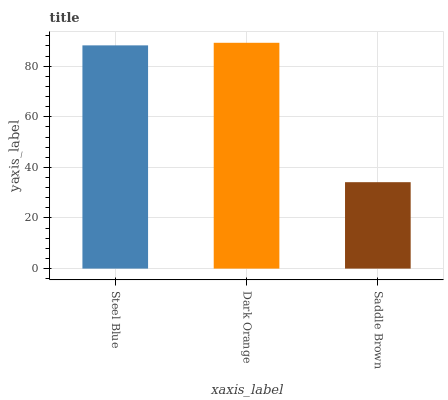Is Dark Orange the minimum?
Answer yes or no. No. Is Saddle Brown the maximum?
Answer yes or no. No. Is Dark Orange greater than Saddle Brown?
Answer yes or no. Yes. Is Saddle Brown less than Dark Orange?
Answer yes or no. Yes. Is Saddle Brown greater than Dark Orange?
Answer yes or no. No. Is Dark Orange less than Saddle Brown?
Answer yes or no. No. Is Steel Blue the high median?
Answer yes or no. Yes. Is Steel Blue the low median?
Answer yes or no. Yes. Is Saddle Brown the high median?
Answer yes or no. No. Is Saddle Brown the low median?
Answer yes or no. No. 